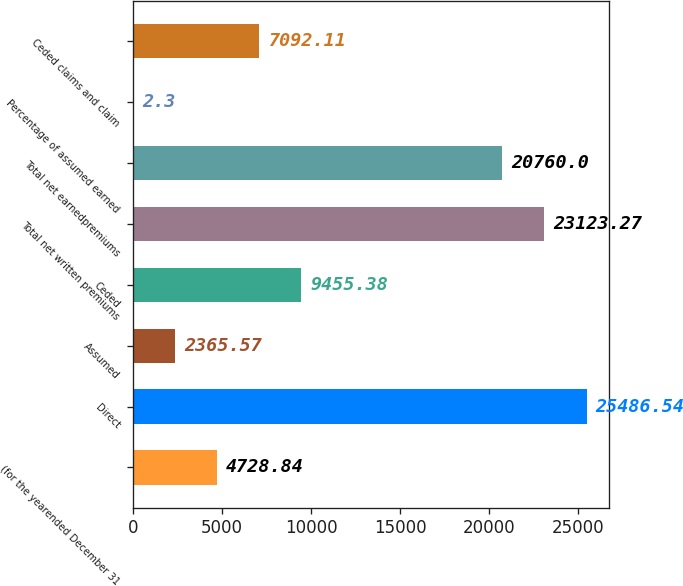Convert chart. <chart><loc_0><loc_0><loc_500><loc_500><bar_chart><fcel>(for the yearended December 31<fcel>Direct<fcel>Assumed<fcel>Ceded<fcel>Total net written premiums<fcel>Total net earnedpremiums<fcel>Percentage of assumed earned<fcel>Ceded claims and claim<nl><fcel>4728.84<fcel>25486.5<fcel>2365.57<fcel>9455.38<fcel>23123.3<fcel>20760<fcel>2.3<fcel>7092.11<nl></chart> 